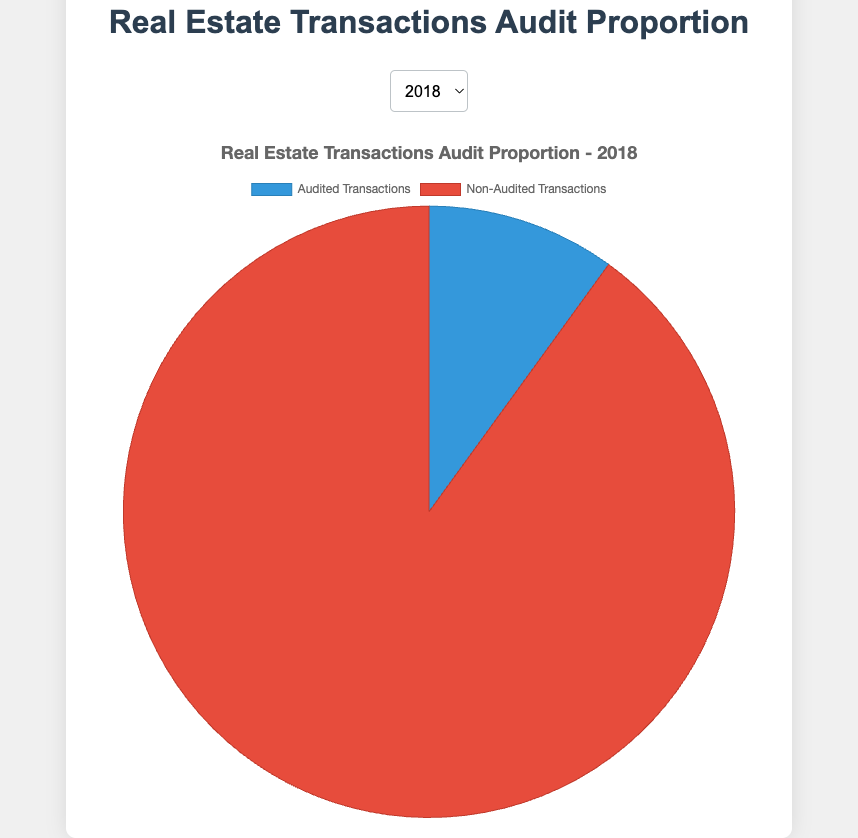What's the total number of Real Estate Transactions in 2021? In 2021, the total number of transactions can be calculated by adding audited transactions (2200) and non-audited transactions (12800): 2200 + 12800.
Answer: 15000 How does the proportion of audited transactions in 2020 compare to 2018? To determine this, compare the percentage of audited transactions in each year. For 2018, percentage = (1500 / (1500 + 13500)) * 100 ≈ 10%. For 2020, percentage = (2000 / (2000 + 13000)) * 100 ≈ 13.33%.
Answer: The proportion is higher in 2020 Which year had the highest proportion of audited transactions? Calculate the percentage of audited transactions for each year and compare. 2018: 10%, 2019: 11.34%, 2020: 13.33%, 2021: 14.67%, 2022: 16.67%.
Answer: 2022 What is the difference in the number of audited transactions between 2019 and 2022? Subtract the audited transactions in 2019 (1700) from those in 2022 (2500): 2500 - 1700.
Answer: 800 What is the average number of non-audited transactions over the five years? Sum the non-audited transactions for each year and divide by 5: (13500 + 13300 + 13000 + 12800 + 12500) / 5.
Answer: 13020 What is the percentage increase in audited transactions from 2018 to 2022? Find the difference in audited transactions between the two years and divide by the 2018 value, then multiply by 100: ((2500 - 1500) / 1500) * 100.
Answer: 66.67% In which year did the share of audited transactions exceed 15% of total transactions for the first time? Calculate the percentage for each year: 2018: 10%, 2019: 11.34%, 2020: 13.33%, 2021: 14.67%, 2022: 16.67%.
Answer: 2022 How many more transactions were non-audited versus audited in 2021? Subtract the audited number from non-audited number in 2021: 12800 - 2200.
Answer: 10600 If a pie chart is shown for 2020, what color represents audited transactions? According to the provided code, audited transactions are represented by the color blue.
Answer: Blue What trend can be observed regarding the number of audited transactions from 2018 to 2022? The number of audited transactions increases each year: 1500, 1700, 2000, 2200, 2500.
Answer: Increasing trend 